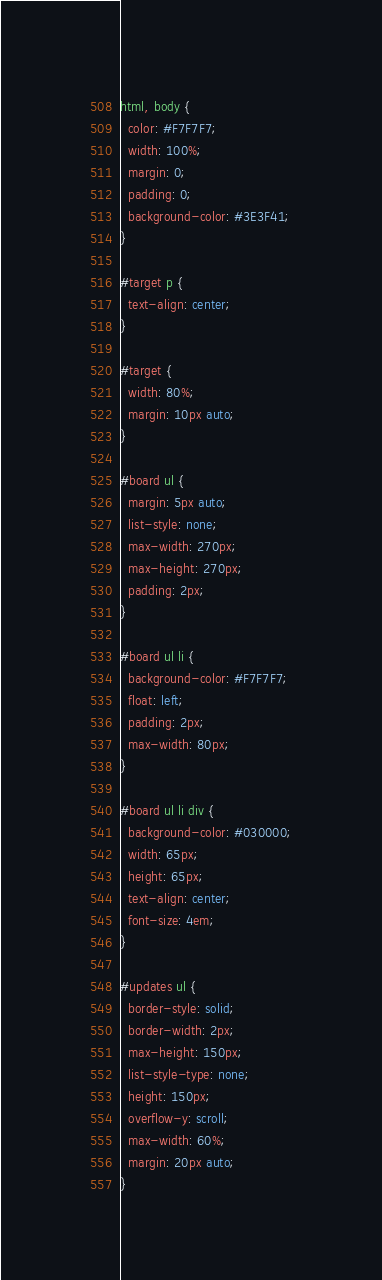<code> <loc_0><loc_0><loc_500><loc_500><_CSS_>html, body {
  color: #F7F7F7;
  width: 100%;
  margin: 0;
  padding: 0;
  background-color: #3E3F41;
}

#target p {
  text-align: center;
}

#target {
  width: 80%;
  margin: 10px auto;
}

#board ul {
  margin: 5px auto;
  list-style: none;
  max-width: 270px;
  max-height: 270px;
  padding: 2px;
}

#board ul li {
  background-color: #F7F7F7;
  float: left;
  padding: 2px;
  max-width: 80px;
}

#board ul li div {
  background-color: #030000;
  width: 65px;
  height: 65px;
  text-align: center;
  font-size: 4em;
}

#updates ul {
  border-style: solid;
  border-width: 2px;
  max-height: 150px;
  list-style-type: none;
  height: 150px;
  overflow-y: scroll;
  max-width: 60%;
  margin: 20px auto;
}
</code> 